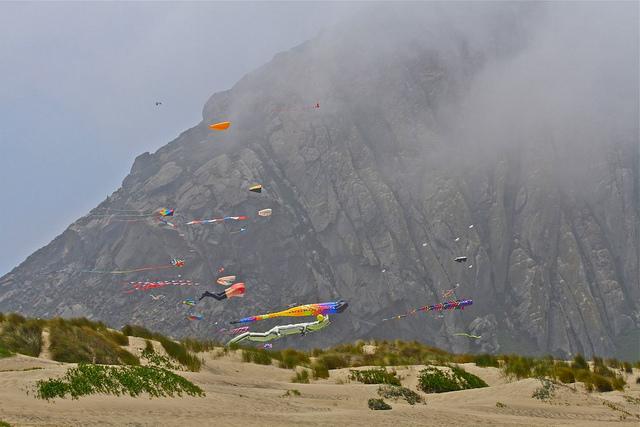How many kites are in this picture?
Write a very short answer. 14. Is the picture colorful?
Quick response, please. Yes. Is there snow on the mountains?
Quick response, please. No. Is it a clear day?
Give a very brief answer. No. Are all of these kites the same design?
Answer briefly. No. Is it cloudy?
Short answer required. Yes. 